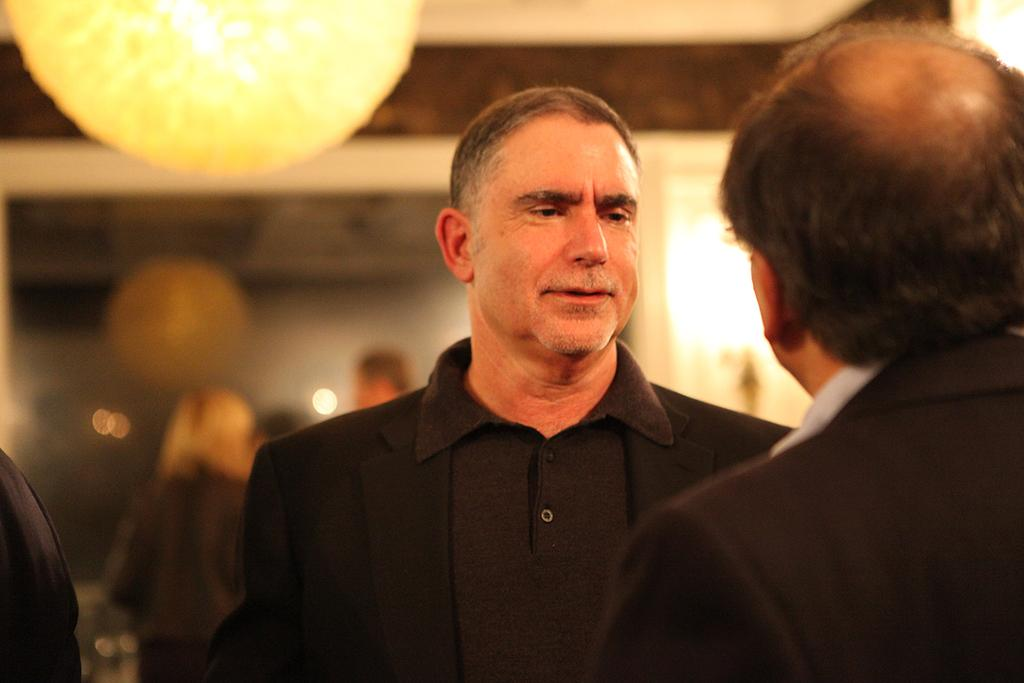How many people are in the image? There are two men in the image. Can you describe any objects or features in the image? There is a light in the image. What type of crown is worn by the men in the image? There are no crowns present in the image; the men are not wearing any headwear. 